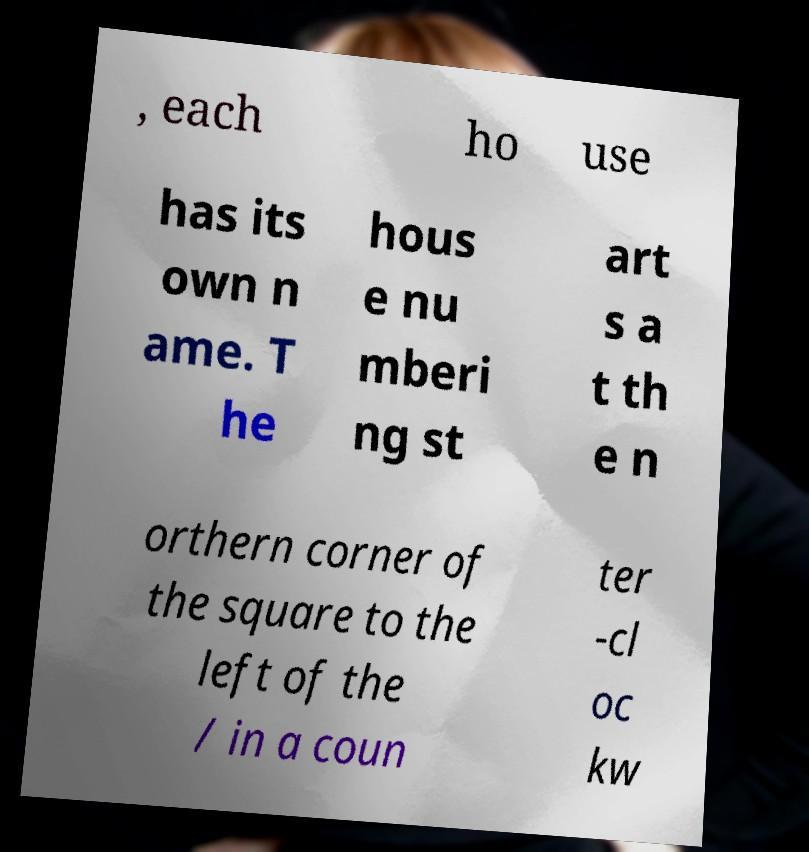What messages or text are displayed in this image? I need them in a readable, typed format. , each ho use has its own n ame. T he hous e nu mberi ng st art s a t th e n orthern corner of the square to the left of the / in a coun ter -cl oc kw 